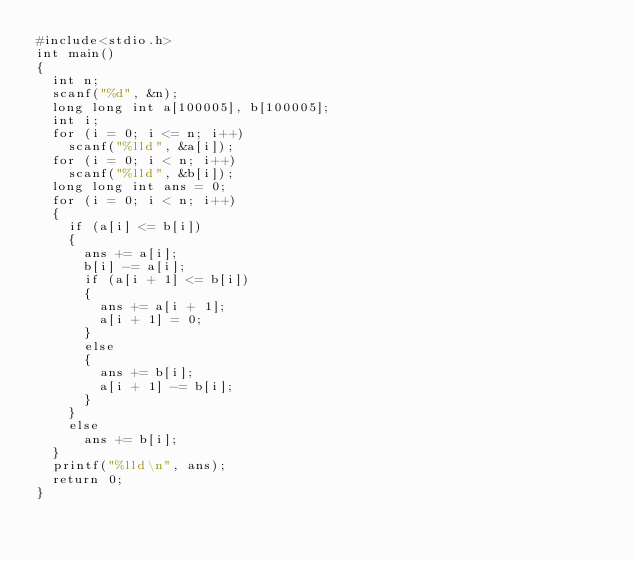<code> <loc_0><loc_0><loc_500><loc_500><_C_>#include<stdio.h>
int main()
{
	int n;
	scanf("%d", &n);
	long long int a[100005], b[100005];
	int i;
	for (i = 0; i <= n; i++)
		scanf("%lld", &a[i]);
	for (i = 0; i < n; i++)
		scanf("%lld", &b[i]);
	long long int ans = 0;
	for (i = 0; i < n; i++)
	{
		if (a[i] <= b[i])
		{
			ans += a[i];
			b[i] -= a[i];
			if (a[i + 1] <= b[i])
			{
				ans += a[i + 1];
				a[i + 1] = 0;
			}
			else
			{
				ans += b[i];
				a[i + 1] -= b[i];
			}
		}
		else
			ans += b[i];
	}
	printf("%lld\n", ans);
	return 0;
}</code> 